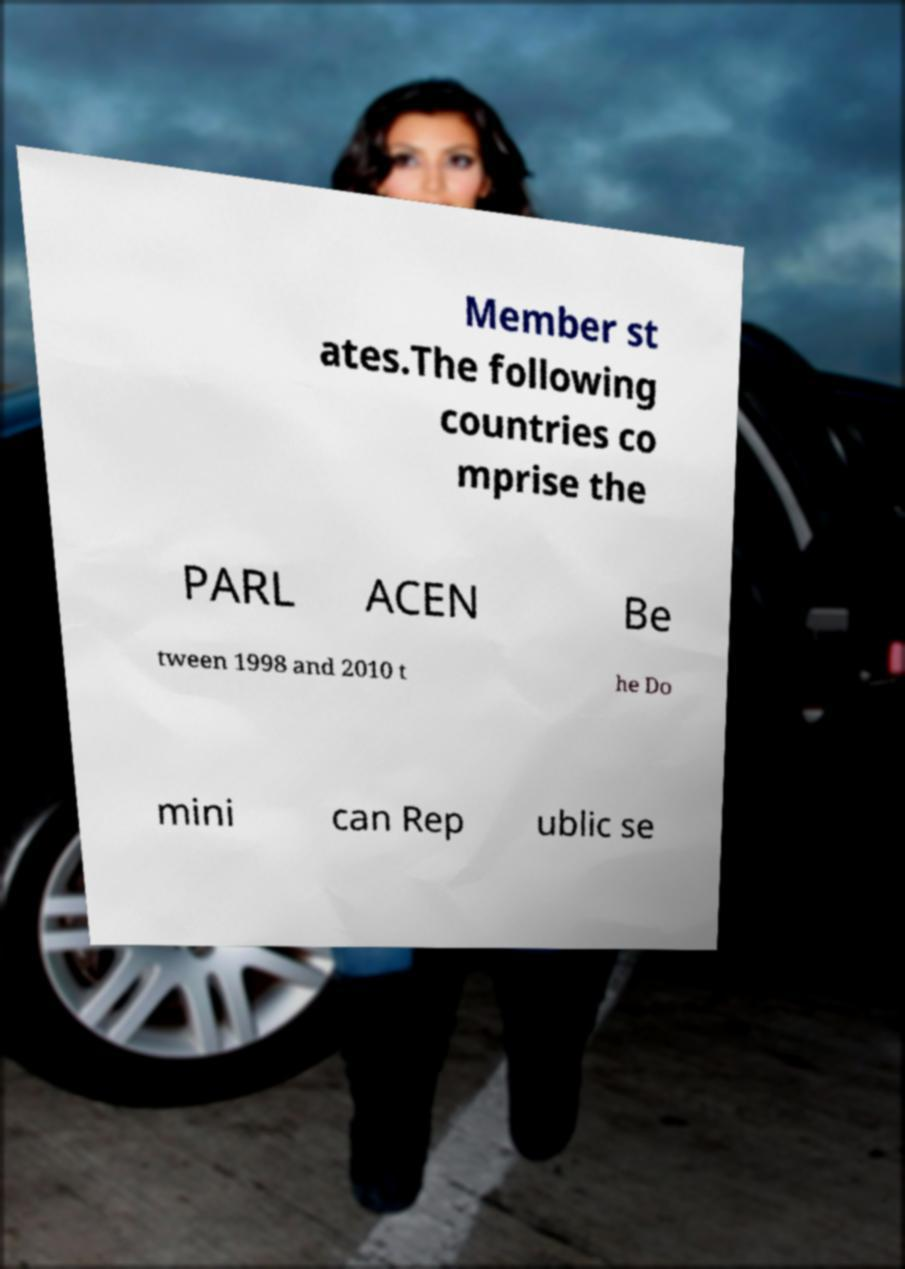I need the written content from this picture converted into text. Can you do that? Member st ates.The following countries co mprise the PARL ACEN Be tween 1998 and 2010 t he Do mini can Rep ublic se 